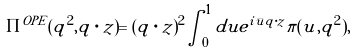<formula> <loc_0><loc_0><loc_500><loc_500>\Pi ^ { O P E } ( q ^ { 2 } , q \cdot z ) = ( q \cdot z ) ^ { 2 } \int _ { 0 } ^ { 1 } d u e ^ { i \bar { u } q \cdot z } \pi ( u , q ^ { 2 } ) ,</formula> 